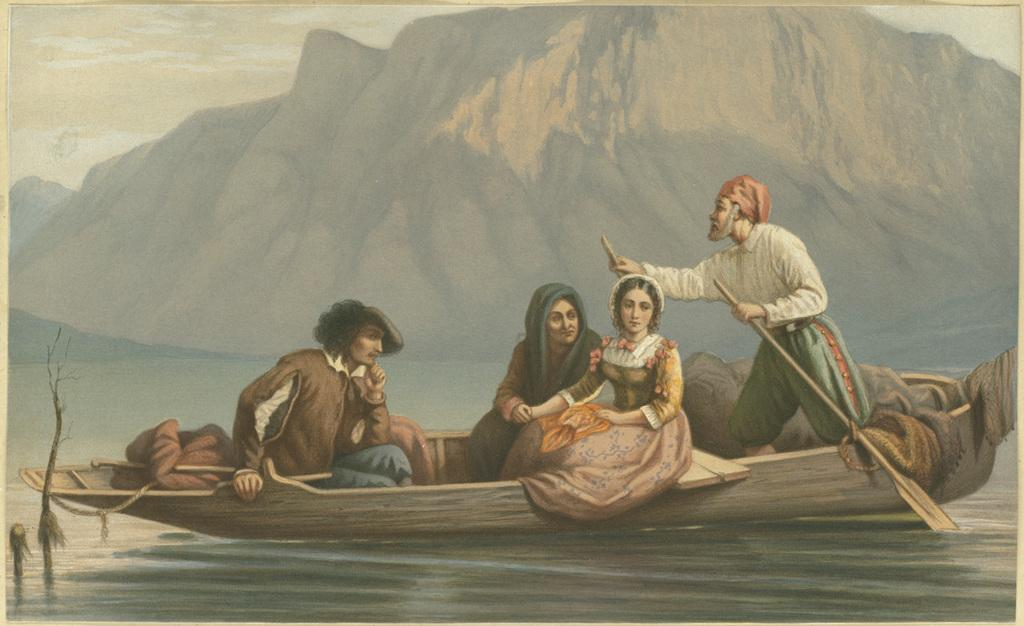What is the main subject of the image? The image contains a painting. What is happening in the painting? The painting depicts a few persons sailing in a boat. What is the boat situated on? The boat is on water. What can be seen in the background of the painting? There is a mountain visible in the background of the painting. What type of grass is growing on the point in the image? There is no grass or point present in the image; it features a painting of persons sailing in a boat on water with a mountain in the background. 